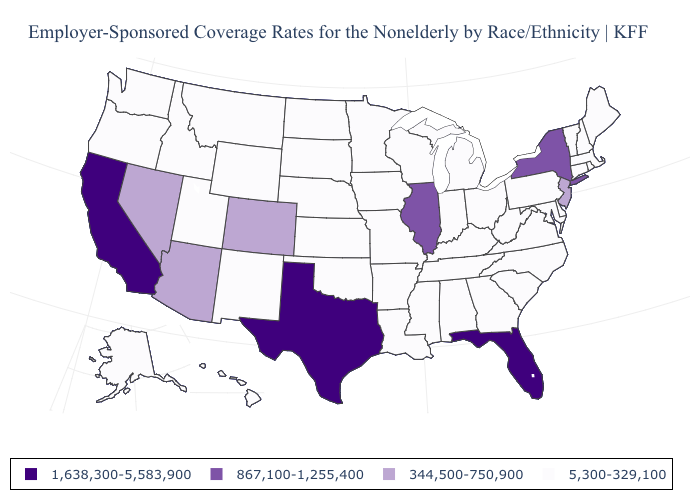Name the states that have a value in the range 5,300-329,100?
Give a very brief answer. Alabama, Alaska, Arkansas, Connecticut, Delaware, Georgia, Hawaii, Idaho, Indiana, Iowa, Kansas, Kentucky, Louisiana, Maine, Maryland, Massachusetts, Michigan, Minnesota, Mississippi, Missouri, Montana, Nebraska, New Hampshire, New Mexico, North Carolina, North Dakota, Ohio, Oklahoma, Oregon, Pennsylvania, Rhode Island, South Carolina, South Dakota, Tennessee, Utah, Vermont, Virginia, Washington, West Virginia, Wisconsin, Wyoming. Name the states that have a value in the range 1,638,300-5,583,900?
Give a very brief answer. California, Florida, Texas. Does the map have missing data?
Answer briefly. No. Is the legend a continuous bar?
Give a very brief answer. No. What is the lowest value in the South?
Short answer required. 5,300-329,100. Does Michigan have a lower value than New Jersey?
Give a very brief answer. Yes. Among the states that border Maryland , which have the highest value?
Concise answer only. Delaware, Pennsylvania, Virginia, West Virginia. Name the states that have a value in the range 867,100-1,255,400?
Answer briefly. Illinois, New York. Name the states that have a value in the range 1,638,300-5,583,900?
Write a very short answer. California, Florida, Texas. Among the states that border Florida , which have the lowest value?
Quick response, please. Alabama, Georgia. What is the value of North Dakota?
Write a very short answer. 5,300-329,100. What is the highest value in states that border Texas?
Give a very brief answer. 5,300-329,100. Among the states that border Virginia , which have the highest value?
Write a very short answer. Kentucky, Maryland, North Carolina, Tennessee, West Virginia. What is the highest value in the MidWest ?
Answer briefly. 867,100-1,255,400. Name the states that have a value in the range 1,638,300-5,583,900?
Answer briefly. California, Florida, Texas. 